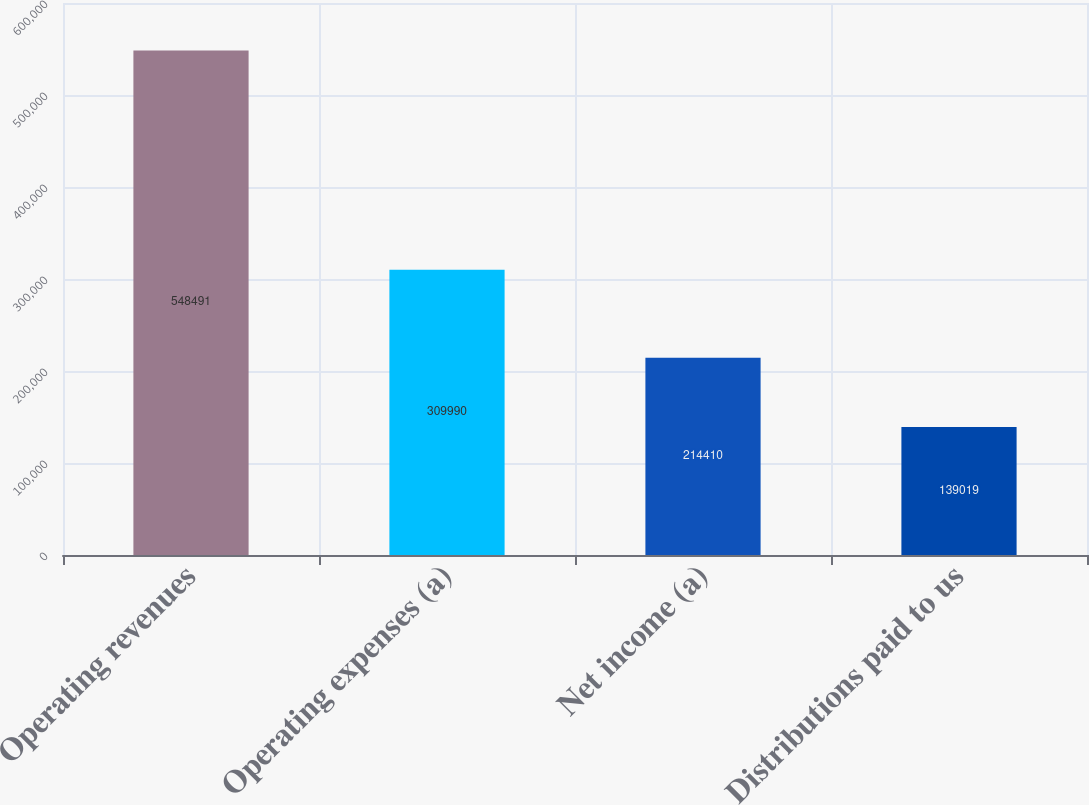Convert chart to OTSL. <chart><loc_0><loc_0><loc_500><loc_500><bar_chart><fcel>Operating revenues<fcel>Operating expenses (a)<fcel>Net income (a)<fcel>Distributions paid to us<nl><fcel>548491<fcel>309990<fcel>214410<fcel>139019<nl></chart> 